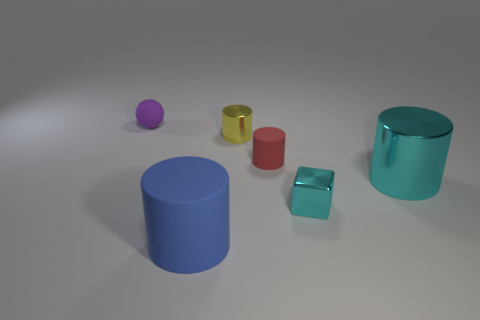Are there any other things that have the same shape as the tiny purple matte object?
Provide a short and direct response. No. There is a big object behind the big matte thing; is its color the same as the tiny object in front of the big cyan shiny thing?
Your response must be concise. Yes. Are there fewer shiny blocks right of the tiny cyan cube than big cyan things to the right of the small purple matte ball?
Offer a terse response. Yes. What is the shape of the tiny metal thing that is behind the tiny red rubber cylinder?
Your answer should be very brief. Cylinder. There is a cylinder that is the same color as the small block; what is it made of?
Your answer should be very brief. Metal. There is a small cyan metallic thing; does it have the same shape as the small object behind the tiny metal cylinder?
Ensure brevity in your answer.  No. The large blue thing that is made of the same material as the red cylinder is what shape?
Provide a succinct answer. Cylinder. Are there more rubber things that are in front of the tiny red cylinder than shiny cubes that are behind the cyan metallic block?
Your answer should be compact. Yes. What number of things are cyan metallic blocks or small matte spheres?
Your answer should be very brief. 2. How many other things are there of the same color as the metal block?
Offer a terse response. 1. 